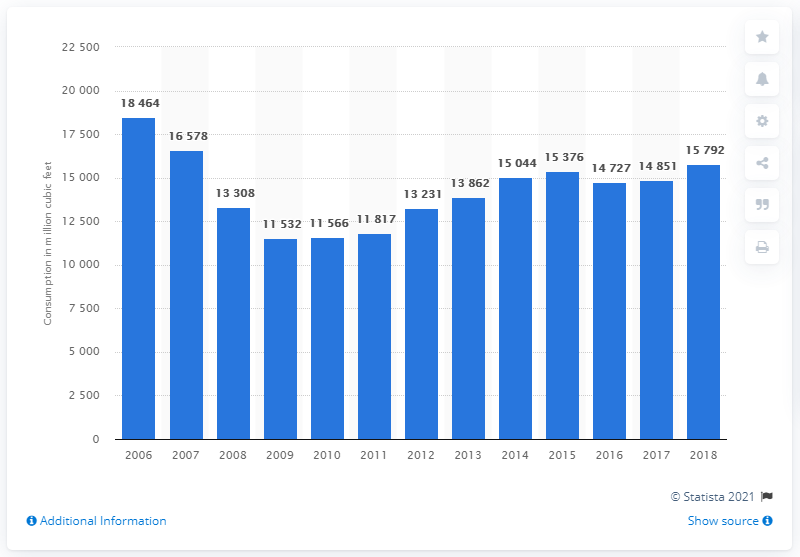Mention a couple of crucial points in this snapshot. In 2018, the total consumption of industrial roundwood in the United States was 15,792 cubic feet. 